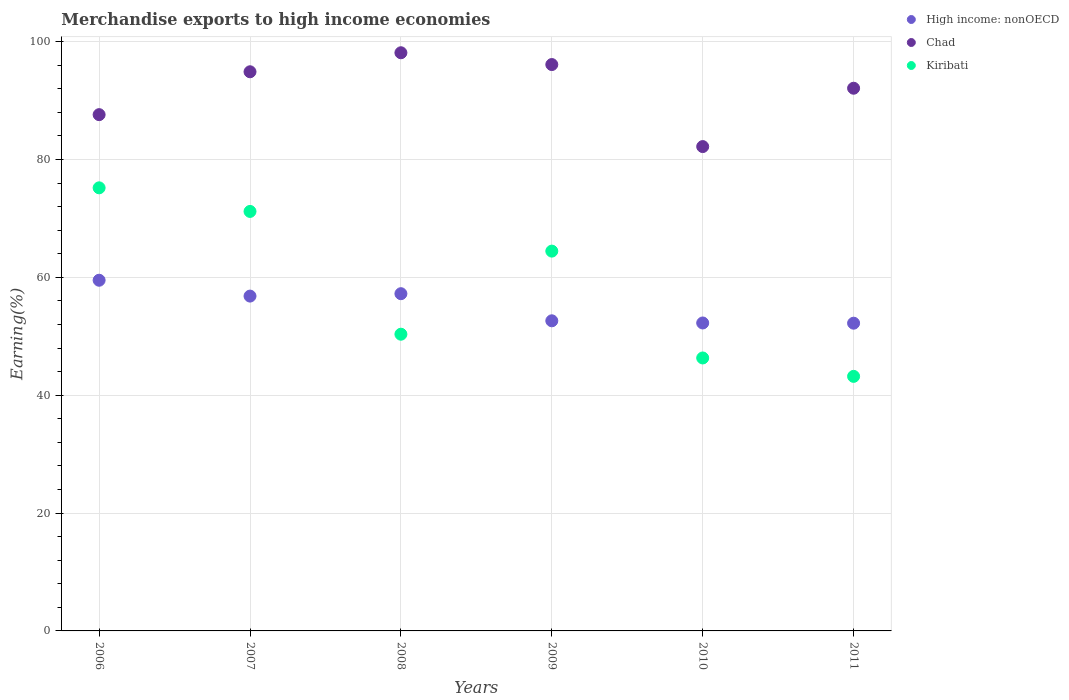How many different coloured dotlines are there?
Keep it short and to the point. 3. Is the number of dotlines equal to the number of legend labels?
Provide a short and direct response. Yes. What is the percentage of amount earned from merchandise exports in Chad in 2008?
Make the answer very short. 98.11. Across all years, what is the maximum percentage of amount earned from merchandise exports in Kiribati?
Your response must be concise. 75.19. Across all years, what is the minimum percentage of amount earned from merchandise exports in Kiribati?
Keep it short and to the point. 43.2. In which year was the percentage of amount earned from merchandise exports in High income: nonOECD maximum?
Your answer should be compact. 2006. In which year was the percentage of amount earned from merchandise exports in Chad minimum?
Offer a very short reply. 2010. What is the total percentage of amount earned from merchandise exports in Kiribati in the graph?
Offer a very short reply. 350.7. What is the difference between the percentage of amount earned from merchandise exports in Chad in 2009 and that in 2010?
Your answer should be compact. 13.92. What is the difference between the percentage of amount earned from merchandise exports in Kiribati in 2011 and the percentage of amount earned from merchandise exports in High income: nonOECD in 2009?
Ensure brevity in your answer.  -9.43. What is the average percentage of amount earned from merchandise exports in Kiribati per year?
Give a very brief answer. 58.45. In the year 2009, what is the difference between the percentage of amount earned from merchandise exports in Kiribati and percentage of amount earned from merchandise exports in High income: nonOECD?
Offer a terse response. 11.83. What is the ratio of the percentage of amount earned from merchandise exports in Kiribati in 2009 to that in 2010?
Ensure brevity in your answer.  1.39. Is the difference between the percentage of amount earned from merchandise exports in Kiribati in 2009 and 2011 greater than the difference between the percentage of amount earned from merchandise exports in High income: nonOECD in 2009 and 2011?
Your answer should be very brief. Yes. What is the difference between the highest and the second highest percentage of amount earned from merchandise exports in Chad?
Offer a very short reply. 2. What is the difference between the highest and the lowest percentage of amount earned from merchandise exports in High income: nonOECD?
Offer a terse response. 7.29. In how many years, is the percentage of amount earned from merchandise exports in High income: nonOECD greater than the average percentage of amount earned from merchandise exports in High income: nonOECD taken over all years?
Your response must be concise. 3. Is the percentage of amount earned from merchandise exports in Kiribati strictly less than the percentage of amount earned from merchandise exports in Chad over the years?
Give a very brief answer. Yes. How many dotlines are there?
Your response must be concise. 3. How many years are there in the graph?
Give a very brief answer. 6. What is the difference between two consecutive major ticks on the Y-axis?
Offer a very short reply. 20. Does the graph contain grids?
Keep it short and to the point. Yes. How many legend labels are there?
Make the answer very short. 3. What is the title of the graph?
Offer a very short reply. Merchandise exports to high income economies. Does "San Marino" appear as one of the legend labels in the graph?
Offer a terse response. No. What is the label or title of the Y-axis?
Offer a very short reply. Earning(%). What is the Earning(%) in High income: nonOECD in 2006?
Your response must be concise. 59.51. What is the Earning(%) of Chad in 2006?
Your answer should be very brief. 87.61. What is the Earning(%) in Kiribati in 2006?
Your response must be concise. 75.19. What is the Earning(%) in High income: nonOECD in 2007?
Your answer should be very brief. 56.82. What is the Earning(%) in Chad in 2007?
Your answer should be compact. 94.89. What is the Earning(%) of Kiribati in 2007?
Your response must be concise. 71.19. What is the Earning(%) of High income: nonOECD in 2008?
Your answer should be very brief. 57.23. What is the Earning(%) of Chad in 2008?
Provide a short and direct response. 98.11. What is the Earning(%) in Kiribati in 2008?
Provide a succinct answer. 50.35. What is the Earning(%) of High income: nonOECD in 2009?
Your answer should be compact. 52.63. What is the Earning(%) of Chad in 2009?
Make the answer very short. 96.11. What is the Earning(%) in Kiribati in 2009?
Provide a succinct answer. 64.45. What is the Earning(%) of High income: nonOECD in 2010?
Give a very brief answer. 52.26. What is the Earning(%) in Chad in 2010?
Your response must be concise. 82.19. What is the Earning(%) of Kiribati in 2010?
Keep it short and to the point. 46.32. What is the Earning(%) of High income: nonOECD in 2011?
Your answer should be compact. 52.22. What is the Earning(%) in Chad in 2011?
Ensure brevity in your answer.  92.09. What is the Earning(%) of Kiribati in 2011?
Your response must be concise. 43.2. Across all years, what is the maximum Earning(%) in High income: nonOECD?
Keep it short and to the point. 59.51. Across all years, what is the maximum Earning(%) in Chad?
Offer a very short reply. 98.11. Across all years, what is the maximum Earning(%) of Kiribati?
Offer a very short reply. 75.19. Across all years, what is the minimum Earning(%) in High income: nonOECD?
Offer a very short reply. 52.22. Across all years, what is the minimum Earning(%) in Chad?
Provide a succinct answer. 82.19. Across all years, what is the minimum Earning(%) of Kiribati?
Make the answer very short. 43.2. What is the total Earning(%) in High income: nonOECD in the graph?
Your answer should be compact. 330.66. What is the total Earning(%) in Chad in the graph?
Ensure brevity in your answer.  551.01. What is the total Earning(%) in Kiribati in the graph?
Make the answer very short. 350.7. What is the difference between the Earning(%) of High income: nonOECD in 2006 and that in 2007?
Keep it short and to the point. 2.69. What is the difference between the Earning(%) of Chad in 2006 and that in 2007?
Your response must be concise. -7.28. What is the difference between the Earning(%) in Kiribati in 2006 and that in 2007?
Provide a succinct answer. 4.01. What is the difference between the Earning(%) in High income: nonOECD in 2006 and that in 2008?
Make the answer very short. 2.28. What is the difference between the Earning(%) in Chad in 2006 and that in 2008?
Your answer should be compact. -10.5. What is the difference between the Earning(%) in Kiribati in 2006 and that in 2008?
Provide a short and direct response. 24.84. What is the difference between the Earning(%) in High income: nonOECD in 2006 and that in 2009?
Provide a short and direct response. 6.88. What is the difference between the Earning(%) of Chad in 2006 and that in 2009?
Provide a short and direct response. -8.5. What is the difference between the Earning(%) in Kiribati in 2006 and that in 2009?
Provide a succinct answer. 10.74. What is the difference between the Earning(%) in High income: nonOECD in 2006 and that in 2010?
Keep it short and to the point. 7.25. What is the difference between the Earning(%) of Chad in 2006 and that in 2010?
Make the answer very short. 5.42. What is the difference between the Earning(%) in Kiribati in 2006 and that in 2010?
Your answer should be very brief. 28.87. What is the difference between the Earning(%) of High income: nonOECD in 2006 and that in 2011?
Your answer should be compact. 7.29. What is the difference between the Earning(%) of Chad in 2006 and that in 2011?
Your response must be concise. -4.48. What is the difference between the Earning(%) of Kiribati in 2006 and that in 2011?
Ensure brevity in your answer.  31.99. What is the difference between the Earning(%) of High income: nonOECD in 2007 and that in 2008?
Your answer should be compact. -0.41. What is the difference between the Earning(%) of Chad in 2007 and that in 2008?
Make the answer very short. -3.23. What is the difference between the Earning(%) in Kiribati in 2007 and that in 2008?
Your response must be concise. 20.84. What is the difference between the Earning(%) in High income: nonOECD in 2007 and that in 2009?
Your answer should be compact. 4.19. What is the difference between the Earning(%) in Chad in 2007 and that in 2009?
Keep it short and to the point. -1.23. What is the difference between the Earning(%) in Kiribati in 2007 and that in 2009?
Your answer should be very brief. 6.73. What is the difference between the Earning(%) of High income: nonOECD in 2007 and that in 2010?
Your answer should be very brief. 4.56. What is the difference between the Earning(%) of Chad in 2007 and that in 2010?
Your answer should be very brief. 12.69. What is the difference between the Earning(%) of Kiribati in 2007 and that in 2010?
Ensure brevity in your answer.  24.87. What is the difference between the Earning(%) in High income: nonOECD in 2007 and that in 2011?
Give a very brief answer. 4.6. What is the difference between the Earning(%) in Chad in 2007 and that in 2011?
Offer a very short reply. 2.79. What is the difference between the Earning(%) of Kiribati in 2007 and that in 2011?
Your response must be concise. 27.99. What is the difference between the Earning(%) of High income: nonOECD in 2008 and that in 2009?
Ensure brevity in your answer.  4.6. What is the difference between the Earning(%) of Chad in 2008 and that in 2009?
Provide a succinct answer. 2. What is the difference between the Earning(%) in Kiribati in 2008 and that in 2009?
Give a very brief answer. -14.1. What is the difference between the Earning(%) of High income: nonOECD in 2008 and that in 2010?
Offer a terse response. 4.97. What is the difference between the Earning(%) in Chad in 2008 and that in 2010?
Provide a succinct answer. 15.92. What is the difference between the Earning(%) in Kiribati in 2008 and that in 2010?
Your answer should be compact. 4.03. What is the difference between the Earning(%) of High income: nonOECD in 2008 and that in 2011?
Your response must be concise. 5. What is the difference between the Earning(%) of Chad in 2008 and that in 2011?
Make the answer very short. 6.02. What is the difference between the Earning(%) of Kiribati in 2008 and that in 2011?
Provide a short and direct response. 7.15. What is the difference between the Earning(%) of High income: nonOECD in 2009 and that in 2010?
Offer a terse response. 0.37. What is the difference between the Earning(%) in Chad in 2009 and that in 2010?
Provide a short and direct response. 13.92. What is the difference between the Earning(%) of Kiribati in 2009 and that in 2010?
Your answer should be very brief. 18.13. What is the difference between the Earning(%) of High income: nonOECD in 2009 and that in 2011?
Keep it short and to the point. 0.41. What is the difference between the Earning(%) in Chad in 2009 and that in 2011?
Your answer should be compact. 4.02. What is the difference between the Earning(%) in Kiribati in 2009 and that in 2011?
Provide a succinct answer. 21.25. What is the difference between the Earning(%) of High income: nonOECD in 2010 and that in 2011?
Offer a terse response. 0.04. What is the difference between the Earning(%) of Chad in 2010 and that in 2011?
Provide a short and direct response. -9.9. What is the difference between the Earning(%) of Kiribati in 2010 and that in 2011?
Provide a short and direct response. 3.12. What is the difference between the Earning(%) in High income: nonOECD in 2006 and the Earning(%) in Chad in 2007?
Offer a very short reply. -35.38. What is the difference between the Earning(%) in High income: nonOECD in 2006 and the Earning(%) in Kiribati in 2007?
Your response must be concise. -11.68. What is the difference between the Earning(%) in Chad in 2006 and the Earning(%) in Kiribati in 2007?
Your response must be concise. 16.43. What is the difference between the Earning(%) of High income: nonOECD in 2006 and the Earning(%) of Chad in 2008?
Ensure brevity in your answer.  -38.6. What is the difference between the Earning(%) of High income: nonOECD in 2006 and the Earning(%) of Kiribati in 2008?
Your answer should be compact. 9.16. What is the difference between the Earning(%) of Chad in 2006 and the Earning(%) of Kiribati in 2008?
Give a very brief answer. 37.26. What is the difference between the Earning(%) of High income: nonOECD in 2006 and the Earning(%) of Chad in 2009?
Provide a succinct answer. -36.6. What is the difference between the Earning(%) of High income: nonOECD in 2006 and the Earning(%) of Kiribati in 2009?
Your answer should be compact. -4.94. What is the difference between the Earning(%) in Chad in 2006 and the Earning(%) in Kiribati in 2009?
Provide a succinct answer. 23.16. What is the difference between the Earning(%) in High income: nonOECD in 2006 and the Earning(%) in Chad in 2010?
Keep it short and to the point. -22.68. What is the difference between the Earning(%) of High income: nonOECD in 2006 and the Earning(%) of Kiribati in 2010?
Offer a very short reply. 13.19. What is the difference between the Earning(%) in Chad in 2006 and the Earning(%) in Kiribati in 2010?
Your response must be concise. 41.29. What is the difference between the Earning(%) in High income: nonOECD in 2006 and the Earning(%) in Chad in 2011?
Give a very brief answer. -32.58. What is the difference between the Earning(%) of High income: nonOECD in 2006 and the Earning(%) of Kiribati in 2011?
Ensure brevity in your answer.  16.31. What is the difference between the Earning(%) of Chad in 2006 and the Earning(%) of Kiribati in 2011?
Your answer should be compact. 44.41. What is the difference between the Earning(%) in High income: nonOECD in 2007 and the Earning(%) in Chad in 2008?
Keep it short and to the point. -41.29. What is the difference between the Earning(%) in High income: nonOECD in 2007 and the Earning(%) in Kiribati in 2008?
Provide a short and direct response. 6.47. What is the difference between the Earning(%) in Chad in 2007 and the Earning(%) in Kiribati in 2008?
Keep it short and to the point. 44.54. What is the difference between the Earning(%) of High income: nonOECD in 2007 and the Earning(%) of Chad in 2009?
Provide a short and direct response. -39.29. What is the difference between the Earning(%) in High income: nonOECD in 2007 and the Earning(%) in Kiribati in 2009?
Provide a succinct answer. -7.63. What is the difference between the Earning(%) in Chad in 2007 and the Earning(%) in Kiribati in 2009?
Offer a terse response. 30.43. What is the difference between the Earning(%) in High income: nonOECD in 2007 and the Earning(%) in Chad in 2010?
Provide a short and direct response. -25.37. What is the difference between the Earning(%) in High income: nonOECD in 2007 and the Earning(%) in Kiribati in 2010?
Provide a short and direct response. 10.5. What is the difference between the Earning(%) of Chad in 2007 and the Earning(%) of Kiribati in 2010?
Provide a short and direct response. 48.57. What is the difference between the Earning(%) of High income: nonOECD in 2007 and the Earning(%) of Chad in 2011?
Offer a terse response. -35.27. What is the difference between the Earning(%) of High income: nonOECD in 2007 and the Earning(%) of Kiribati in 2011?
Offer a very short reply. 13.62. What is the difference between the Earning(%) of Chad in 2007 and the Earning(%) of Kiribati in 2011?
Ensure brevity in your answer.  51.69. What is the difference between the Earning(%) in High income: nonOECD in 2008 and the Earning(%) in Chad in 2009?
Provide a succinct answer. -38.89. What is the difference between the Earning(%) of High income: nonOECD in 2008 and the Earning(%) of Kiribati in 2009?
Ensure brevity in your answer.  -7.23. What is the difference between the Earning(%) in Chad in 2008 and the Earning(%) in Kiribati in 2009?
Ensure brevity in your answer.  33.66. What is the difference between the Earning(%) of High income: nonOECD in 2008 and the Earning(%) of Chad in 2010?
Make the answer very short. -24.97. What is the difference between the Earning(%) in High income: nonOECD in 2008 and the Earning(%) in Kiribati in 2010?
Keep it short and to the point. 10.91. What is the difference between the Earning(%) of Chad in 2008 and the Earning(%) of Kiribati in 2010?
Your answer should be very brief. 51.79. What is the difference between the Earning(%) of High income: nonOECD in 2008 and the Earning(%) of Chad in 2011?
Provide a short and direct response. -34.87. What is the difference between the Earning(%) of High income: nonOECD in 2008 and the Earning(%) of Kiribati in 2011?
Give a very brief answer. 14.03. What is the difference between the Earning(%) of Chad in 2008 and the Earning(%) of Kiribati in 2011?
Provide a short and direct response. 54.92. What is the difference between the Earning(%) of High income: nonOECD in 2009 and the Earning(%) of Chad in 2010?
Offer a very short reply. -29.56. What is the difference between the Earning(%) of High income: nonOECD in 2009 and the Earning(%) of Kiribati in 2010?
Offer a terse response. 6.31. What is the difference between the Earning(%) of Chad in 2009 and the Earning(%) of Kiribati in 2010?
Give a very brief answer. 49.79. What is the difference between the Earning(%) of High income: nonOECD in 2009 and the Earning(%) of Chad in 2011?
Offer a terse response. -39.47. What is the difference between the Earning(%) of High income: nonOECD in 2009 and the Earning(%) of Kiribati in 2011?
Ensure brevity in your answer.  9.43. What is the difference between the Earning(%) in Chad in 2009 and the Earning(%) in Kiribati in 2011?
Provide a short and direct response. 52.91. What is the difference between the Earning(%) of High income: nonOECD in 2010 and the Earning(%) of Chad in 2011?
Ensure brevity in your answer.  -39.84. What is the difference between the Earning(%) in High income: nonOECD in 2010 and the Earning(%) in Kiribati in 2011?
Make the answer very short. 9.06. What is the difference between the Earning(%) in Chad in 2010 and the Earning(%) in Kiribati in 2011?
Make the answer very short. 38.99. What is the average Earning(%) of High income: nonOECD per year?
Give a very brief answer. 55.11. What is the average Earning(%) of Chad per year?
Your answer should be compact. 91.83. What is the average Earning(%) in Kiribati per year?
Your answer should be compact. 58.45. In the year 2006, what is the difference between the Earning(%) in High income: nonOECD and Earning(%) in Chad?
Offer a terse response. -28.1. In the year 2006, what is the difference between the Earning(%) in High income: nonOECD and Earning(%) in Kiribati?
Your response must be concise. -15.68. In the year 2006, what is the difference between the Earning(%) of Chad and Earning(%) of Kiribati?
Make the answer very short. 12.42. In the year 2007, what is the difference between the Earning(%) of High income: nonOECD and Earning(%) of Chad?
Your answer should be compact. -38.07. In the year 2007, what is the difference between the Earning(%) of High income: nonOECD and Earning(%) of Kiribati?
Keep it short and to the point. -14.37. In the year 2007, what is the difference between the Earning(%) in Chad and Earning(%) in Kiribati?
Keep it short and to the point. 23.7. In the year 2008, what is the difference between the Earning(%) of High income: nonOECD and Earning(%) of Chad?
Keep it short and to the point. -40.89. In the year 2008, what is the difference between the Earning(%) in High income: nonOECD and Earning(%) in Kiribati?
Offer a very short reply. 6.88. In the year 2008, what is the difference between the Earning(%) in Chad and Earning(%) in Kiribati?
Offer a very short reply. 47.76. In the year 2009, what is the difference between the Earning(%) of High income: nonOECD and Earning(%) of Chad?
Offer a very short reply. -43.48. In the year 2009, what is the difference between the Earning(%) in High income: nonOECD and Earning(%) in Kiribati?
Offer a very short reply. -11.83. In the year 2009, what is the difference between the Earning(%) of Chad and Earning(%) of Kiribati?
Make the answer very short. 31.66. In the year 2010, what is the difference between the Earning(%) in High income: nonOECD and Earning(%) in Chad?
Your response must be concise. -29.93. In the year 2010, what is the difference between the Earning(%) in High income: nonOECD and Earning(%) in Kiribati?
Your answer should be compact. 5.94. In the year 2010, what is the difference between the Earning(%) in Chad and Earning(%) in Kiribati?
Make the answer very short. 35.87. In the year 2011, what is the difference between the Earning(%) in High income: nonOECD and Earning(%) in Chad?
Your answer should be compact. -39.87. In the year 2011, what is the difference between the Earning(%) of High income: nonOECD and Earning(%) of Kiribati?
Your answer should be very brief. 9.02. In the year 2011, what is the difference between the Earning(%) of Chad and Earning(%) of Kiribati?
Make the answer very short. 48.9. What is the ratio of the Earning(%) of High income: nonOECD in 2006 to that in 2007?
Offer a very short reply. 1.05. What is the ratio of the Earning(%) of Chad in 2006 to that in 2007?
Give a very brief answer. 0.92. What is the ratio of the Earning(%) of Kiribati in 2006 to that in 2007?
Keep it short and to the point. 1.06. What is the ratio of the Earning(%) in High income: nonOECD in 2006 to that in 2008?
Provide a short and direct response. 1.04. What is the ratio of the Earning(%) in Chad in 2006 to that in 2008?
Make the answer very short. 0.89. What is the ratio of the Earning(%) in Kiribati in 2006 to that in 2008?
Give a very brief answer. 1.49. What is the ratio of the Earning(%) of High income: nonOECD in 2006 to that in 2009?
Offer a very short reply. 1.13. What is the ratio of the Earning(%) of Chad in 2006 to that in 2009?
Offer a very short reply. 0.91. What is the ratio of the Earning(%) in Kiribati in 2006 to that in 2009?
Give a very brief answer. 1.17. What is the ratio of the Earning(%) of High income: nonOECD in 2006 to that in 2010?
Offer a terse response. 1.14. What is the ratio of the Earning(%) of Chad in 2006 to that in 2010?
Your answer should be very brief. 1.07. What is the ratio of the Earning(%) of Kiribati in 2006 to that in 2010?
Make the answer very short. 1.62. What is the ratio of the Earning(%) of High income: nonOECD in 2006 to that in 2011?
Make the answer very short. 1.14. What is the ratio of the Earning(%) of Chad in 2006 to that in 2011?
Ensure brevity in your answer.  0.95. What is the ratio of the Earning(%) of Kiribati in 2006 to that in 2011?
Give a very brief answer. 1.74. What is the ratio of the Earning(%) in Chad in 2007 to that in 2008?
Your answer should be compact. 0.97. What is the ratio of the Earning(%) in Kiribati in 2007 to that in 2008?
Ensure brevity in your answer.  1.41. What is the ratio of the Earning(%) in High income: nonOECD in 2007 to that in 2009?
Your answer should be compact. 1.08. What is the ratio of the Earning(%) in Chad in 2007 to that in 2009?
Keep it short and to the point. 0.99. What is the ratio of the Earning(%) of Kiribati in 2007 to that in 2009?
Offer a terse response. 1.1. What is the ratio of the Earning(%) in High income: nonOECD in 2007 to that in 2010?
Offer a terse response. 1.09. What is the ratio of the Earning(%) in Chad in 2007 to that in 2010?
Provide a short and direct response. 1.15. What is the ratio of the Earning(%) in Kiribati in 2007 to that in 2010?
Your answer should be very brief. 1.54. What is the ratio of the Earning(%) in High income: nonOECD in 2007 to that in 2011?
Make the answer very short. 1.09. What is the ratio of the Earning(%) of Chad in 2007 to that in 2011?
Make the answer very short. 1.03. What is the ratio of the Earning(%) in Kiribati in 2007 to that in 2011?
Provide a succinct answer. 1.65. What is the ratio of the Earning(%) of High income: nonOECD in 2008 to that in 2009?
Offer a very short reply. 1.09. What is the ratio of the Earning(%) of Chad in 2008 to that in 2009?
Make the answer very short. 1.02. What is the ratio of the Earning(%) of Kiribati in 2008 to that in 2009?
Give a very brief answer. 0.78. What is the ratio of the Earning(%) of High income: nonOECD in 2008 to that in 2010?
Make the answer very short. 1.1. What is the ratio of the Earning(%) in Chad in 2008 to that in 2010?
Your answer should be compact. 1.19. What is the ratio of the Earning(%) in Kiribati in 2008 to that in 2010?
Your answer should be very brief. 1.09. What is the ratio of the Earning(%) of High income: nonOECD in 2008 to that in 2011?
Your answer should be very brief. 1.1. What is the ratio of the Earning(%) in Chad in 2008 to that in 2011?
Offer a very short reply. 1.07. What is the ratio of the Earning(%) in Kiribati in 2008 to that in 2011?
Offer a very short reply. 1.17. What is the ratio of the Earning(%) in High income: nonOECD in 2009 to that in 2010?
Make the answer very short. 1.01. What is the ratio of the Earning(%) in Chad in 2009 to that in 2010?
Make the answer very short. 1.17. What is the ratio of the Earning(%) of Kiribati in 2009 to that in 2010?
Give a very brief answer. 1.39. What is the ratio of the Earning(%) in High income: nonOECD in 2009 to that in 2011?
Offer a very short reply. 1.01. What is the ratio of the Earning(%) of Chad in 2009 to that in 2011?
Your answer should be very brief. 1.04. What is the ratio of the Earning(%) in Kiribati in 2009 to that in 2011?
Make the answer very short. 1.49. What is the ratio of the Earning(%) in Chad in 2010 to that in 2011?
Offer a terse response. 0.89. What is the ratio of the Earning(%) in Kiribati in 2010 to that in 2011?
Ensure brevity in your answer.  1.07. What is the difference between the highest and the second highest Earning(%) in High income: nonOECD?
Provide a succinct answer. 2.28. What is the difference between the highest and the second highest Earning(%) in Chad?
Keep it short and to the point. 2. What is the difference between the highest and the second highest Earning(%) in Kiribati?
Offer a very short reply. 4.01. What is the difference between the highest and the lowest Earning(%) in High income: nonOECD?
Offer a terse response. 7.29. What is the difference between the highest and the lowest Earning(%) in Chad?
Your answer should be compact. 15.92. What is the difference between the highest and the lowest Earning(%) in Kiribati?
Keep it short and to the point. 31.99. 